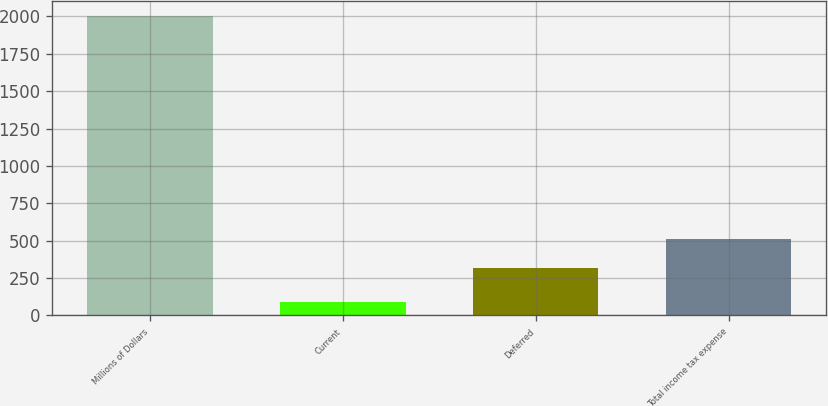Convert chart. <chart><loc_0><loc_0><loc_500><loc_500><bar_chart><fcel>Millions of Dollars<fcel>Current<fcel>Deferred<fcel>Total income tax expense<nl><fcel>2005<fcel>90<fcel>320<fcel>511.5<nl></chart> 